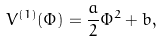<formula> <loc_0><loc_0><loc_500><loc_500>V ^ { ( 1 ) } ( \Phi ) = \frac { a } { 2 } \Phi ^ { 2 } + b ,</formula> 